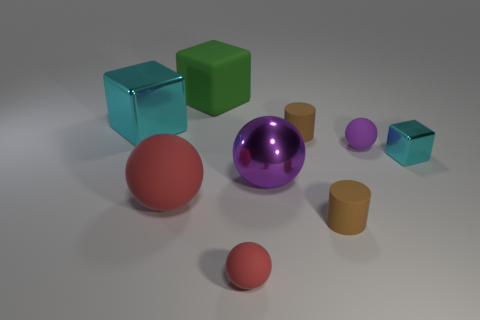What number of things are green objects or cyan metallic blocks that are to the right of the big matte cube?
Your answer should be very brief. 2. Do the small red object and the tiny purple object have the same material?
Provide a succinct answer. Yes. How many other things are there of the same shape as the big red thing?
Ensure brevity in your answer.  3. There is a cube that is to the left of the purple shiny thing and in front of the large matte cube; what size is it?
Your response must be concise. Large. What number of matte objects are either small spheres or tiny blocks?
Ensure brevity in your answer.  2. There is a big rubber object in front of the green cube; does it have the same shape as the small brown thing behind the tiny cyan thing?
Provide a short and direct response. No. Are there any red spheres made of the same material as the big red thing?
Offer a very short reply. Yes. The small block has what color?
Make the answer very short. Cyan. There is a cyan object that is behind the tiny cyan cube; what is its size?
Ensure brevity in your answer.  Large. How many cylinders are the same color as the big rubber block?
Your answer should be very brief. 0. 